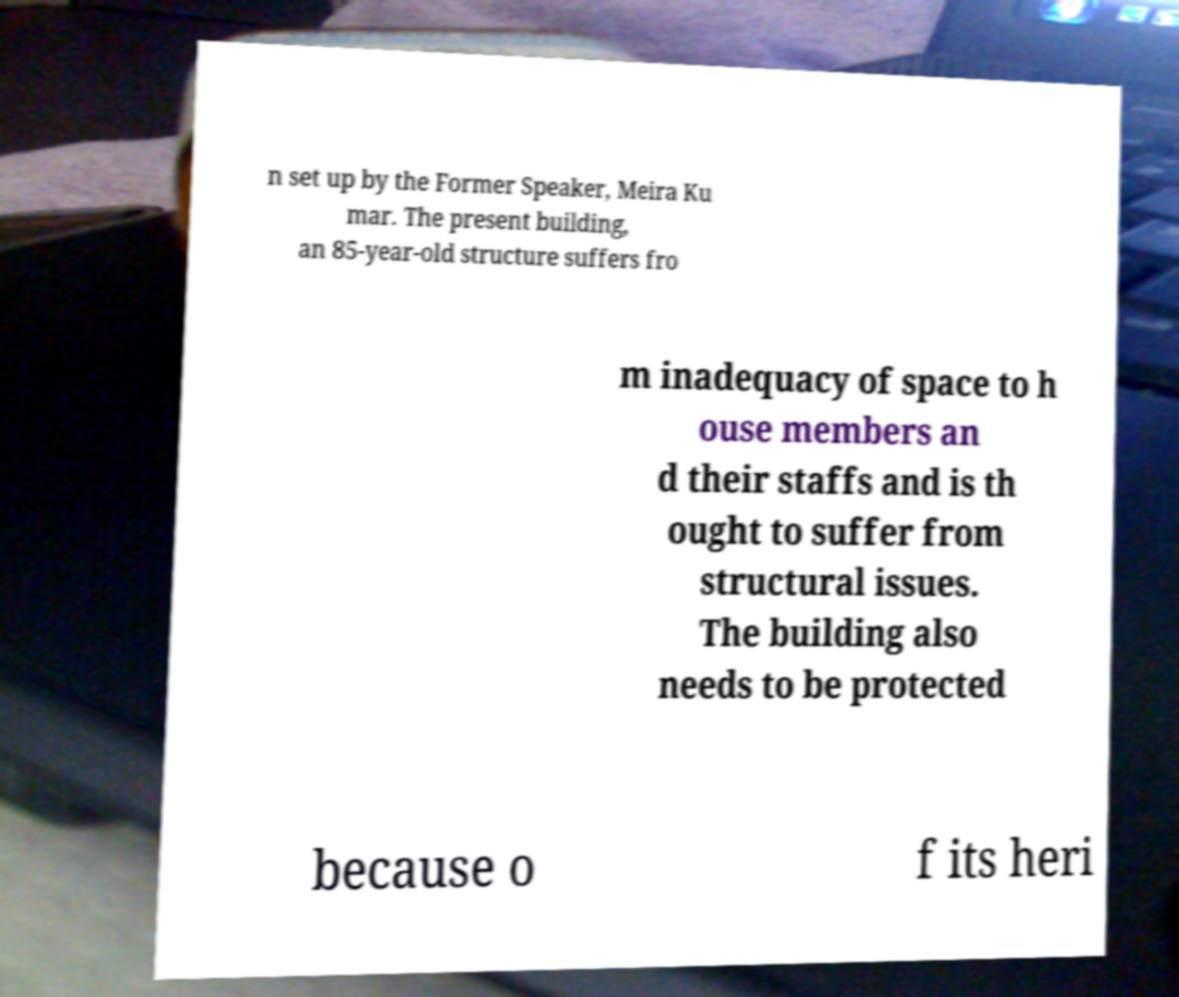For documentation purposes, I need the text within this image transcribed. Could you provide that? n set up by the Former Speaker, Meira Ku mar. The present building, an 85-year-old structure suffers fro m inadequacy of space to h ouse members an d their staffs and is th ought to suffer from structural issues. The building also needs to be protected because o f its heri 